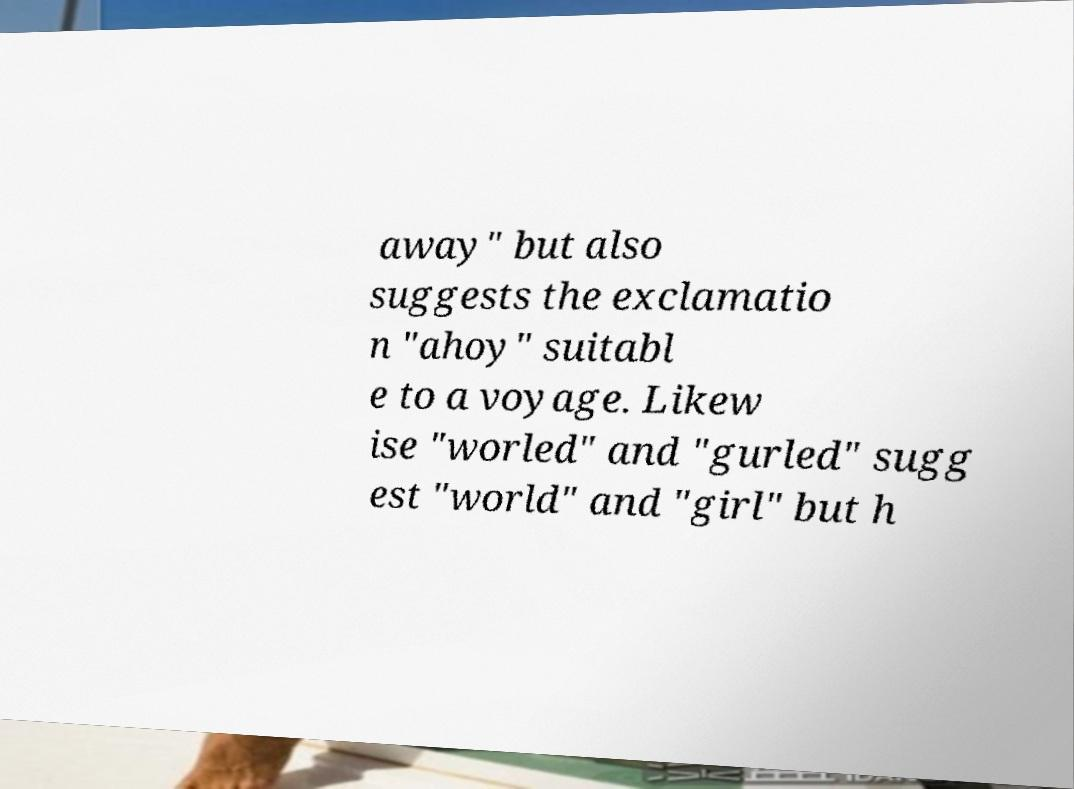Can you read and provide the text displayed in the image?This photo seems to have some interesting text. Can you extract and type it out for me? away" but also suggests the exclamatio n "ahoy" suitabl e to a voyage. Likew ise "worled" and "gurled" sugg est "world" and "girl" but h 